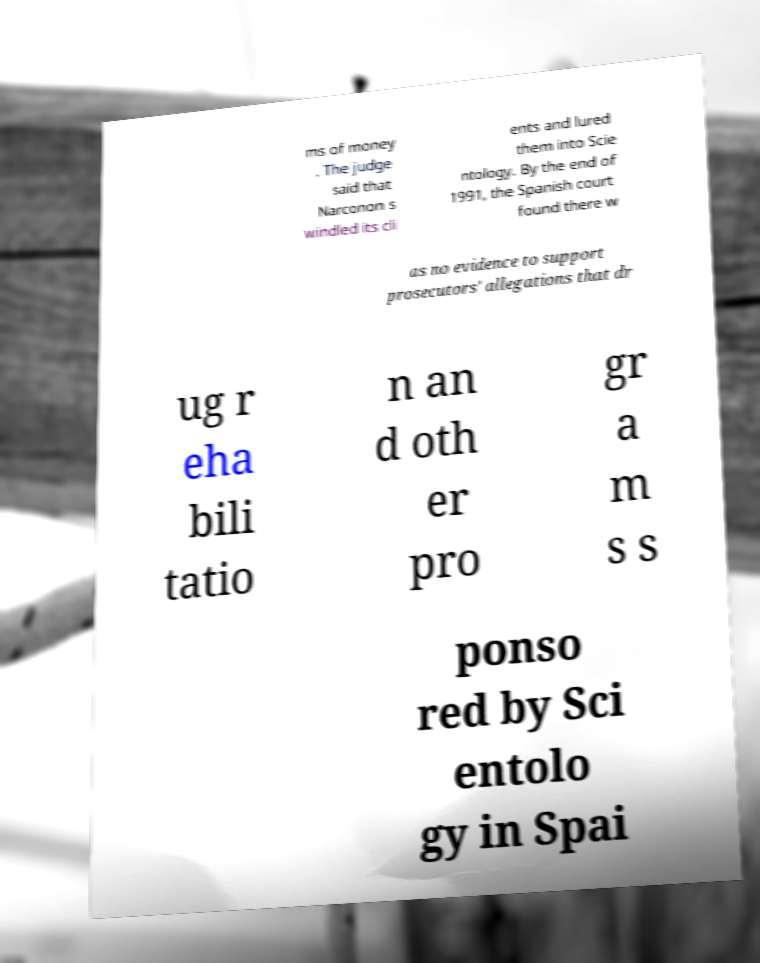What messages or text are displayed in this image? I need them in a readable, typed format. ms of money . The judge said that Narconon s windled its cli ents and lured them into Scie ntology. By the end of 1991, the Spanish court found there w as no evidence to support prosecutors' allegations that dr ug r eha bili tatio n an d oth er pro gr a m s s ponso red by Sci entolo gy in Spai 